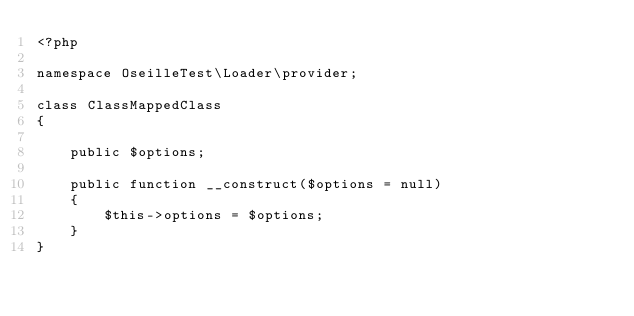Convert code to text. <code><loc_0><loc_0><loc_500><loc_500><_PHP_><?php

namespace OseilleTest\Loader\provider;

class ClassMappedClass
{

    public $options;

    public function __construct($options = null)
    {
        $this->options = $options;
    }
}
</code> 